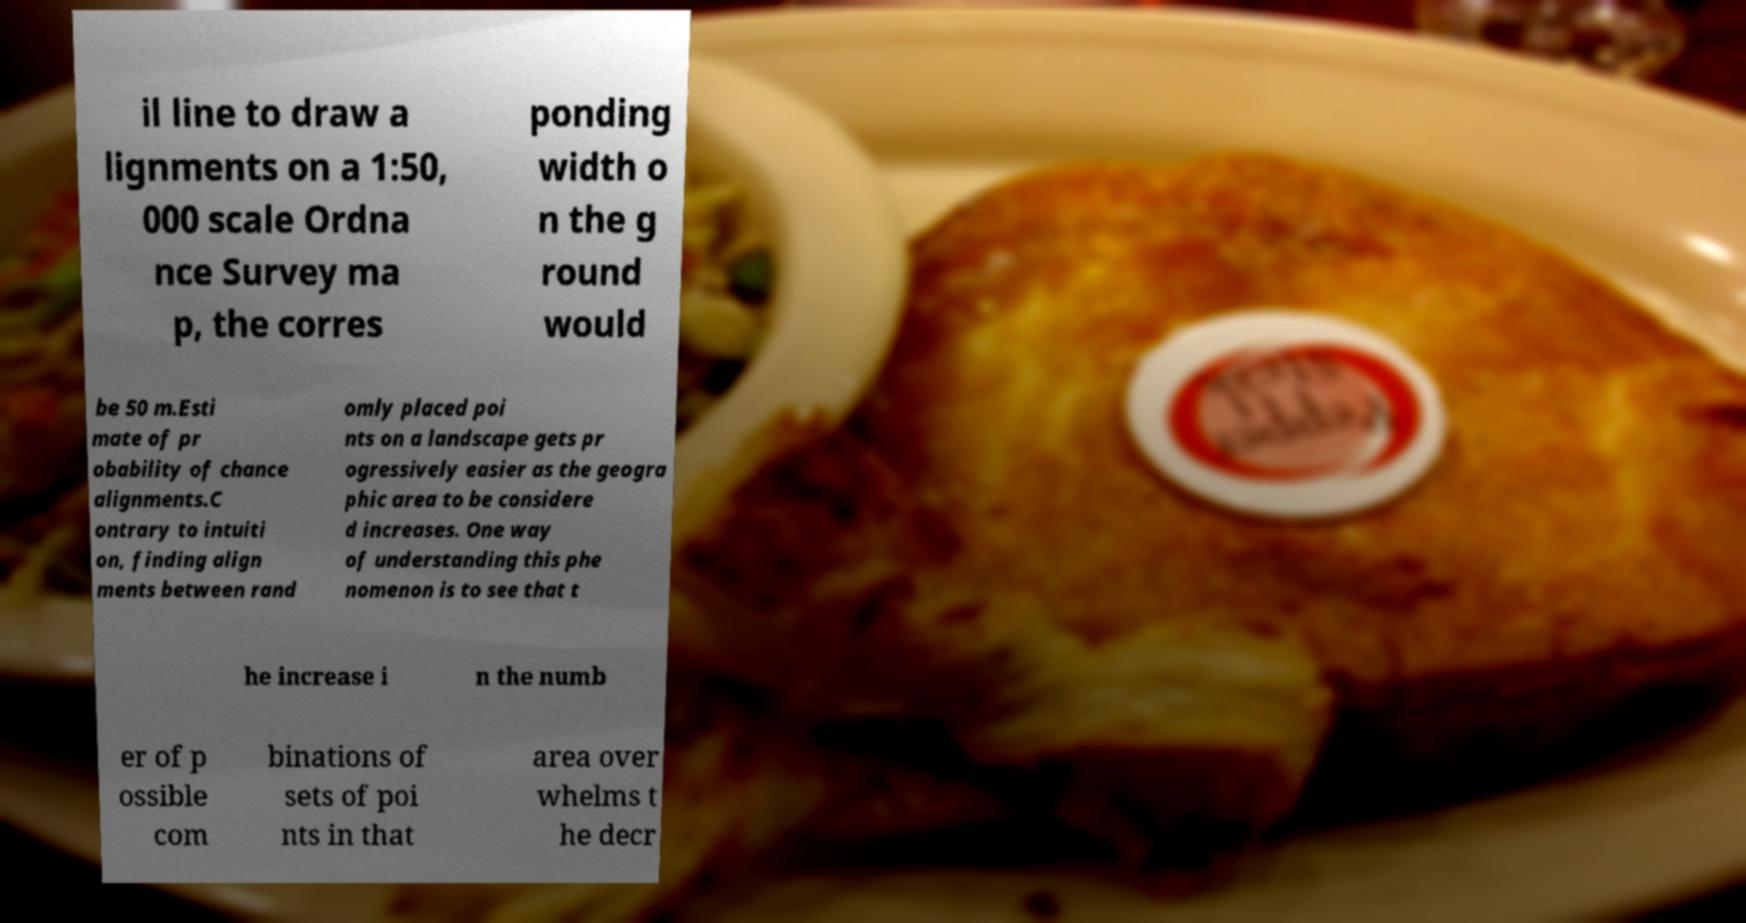There's text embedded in this image that I need extracted. Can you transcribe it verbatim? il line to draw a lignments on a 1:50, 000 scale Ordna nce Survey ma p, the corres ponding width o n the g round would be 50 m.Esti mate of pr obability of chance alignments.C ontrary to intuiti on, finding align ments between rand omly placed poi nts on a landscape gets pr ogressively easier as the geogra phic area to be considere d increases. One way of understanding this phe nomenon is to see that t he increase i n the numb er of p ossible com binations of sets of poi nts in that area over whelms t he decr 